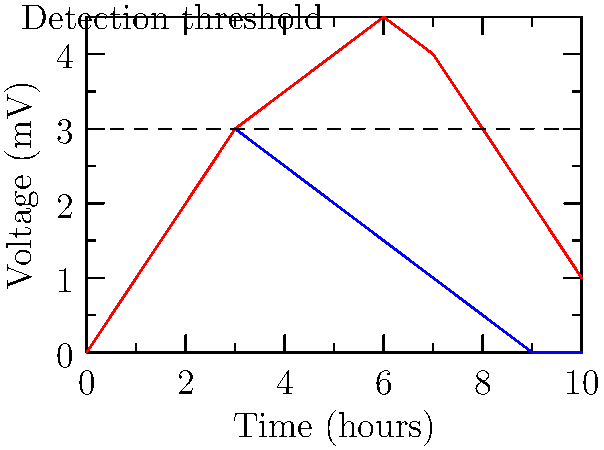In a doping investigation, you're presented with voltage-time graphs for two substances detected in an athlete's sample. Substance A (blue) shows a rapid increase followed by a gradual decline, while Substance B (red) demonstrates a sustained elevation above the detection threshold. Which substance is more likely to be a performance-enhancing drug, and why is this information crucial for your legal defense strategy? To answer this question, we need to analyze the voltage-time graphs for both substances:

1. Substance A (blue line):
   - Rapidly increases to peak at around 3 hours
   - Quickly drops below the detection threshold after 5 hours
   - Completely clears from the system by 10 hours

2. Substance B (red line):
   - Gradually increases and remains above the detection threshold for an extended period
   - Stays elevated for most of the 10-hour window
   - Still detectable at the end of the 10-hour period

3. Characteristics of performance-enhancing drugs:
   - Often designed to have prolonged effects in the body
   - Typically maintain elevated levels for extended periods
   - More likely to be detected in routine drug tests due to longer presence

4. Legal implications:
   - Substance B is more likely to be a performance-enhancing drug due to its sustained presence above the detection threshold
   - This information is crucial for the legal defense strategy because:
     a) It helps identify which substance is more likely to be the cause of the doping violation
     b) It can be used to argue for or against the intentional use of performance-enhancing substances
     c) It may influence the severity of the penalties or sanctions imposed on the athlete or organization

5. Defense strategy considerations:
   - If defending the athlete/organization, focus on Substance A's rapid clearance as potentially an inadvertent exposure or legitimate medication
   - If Substance B is the cause of the violation, investigate possible contamination or unintentional ingestion due to its prolonged presence
Answer: Substance B; crucial for identifying the likely performance-enhancing substance and developing an appropriate legal defense strategy based on its pharmacokinetic profile. 